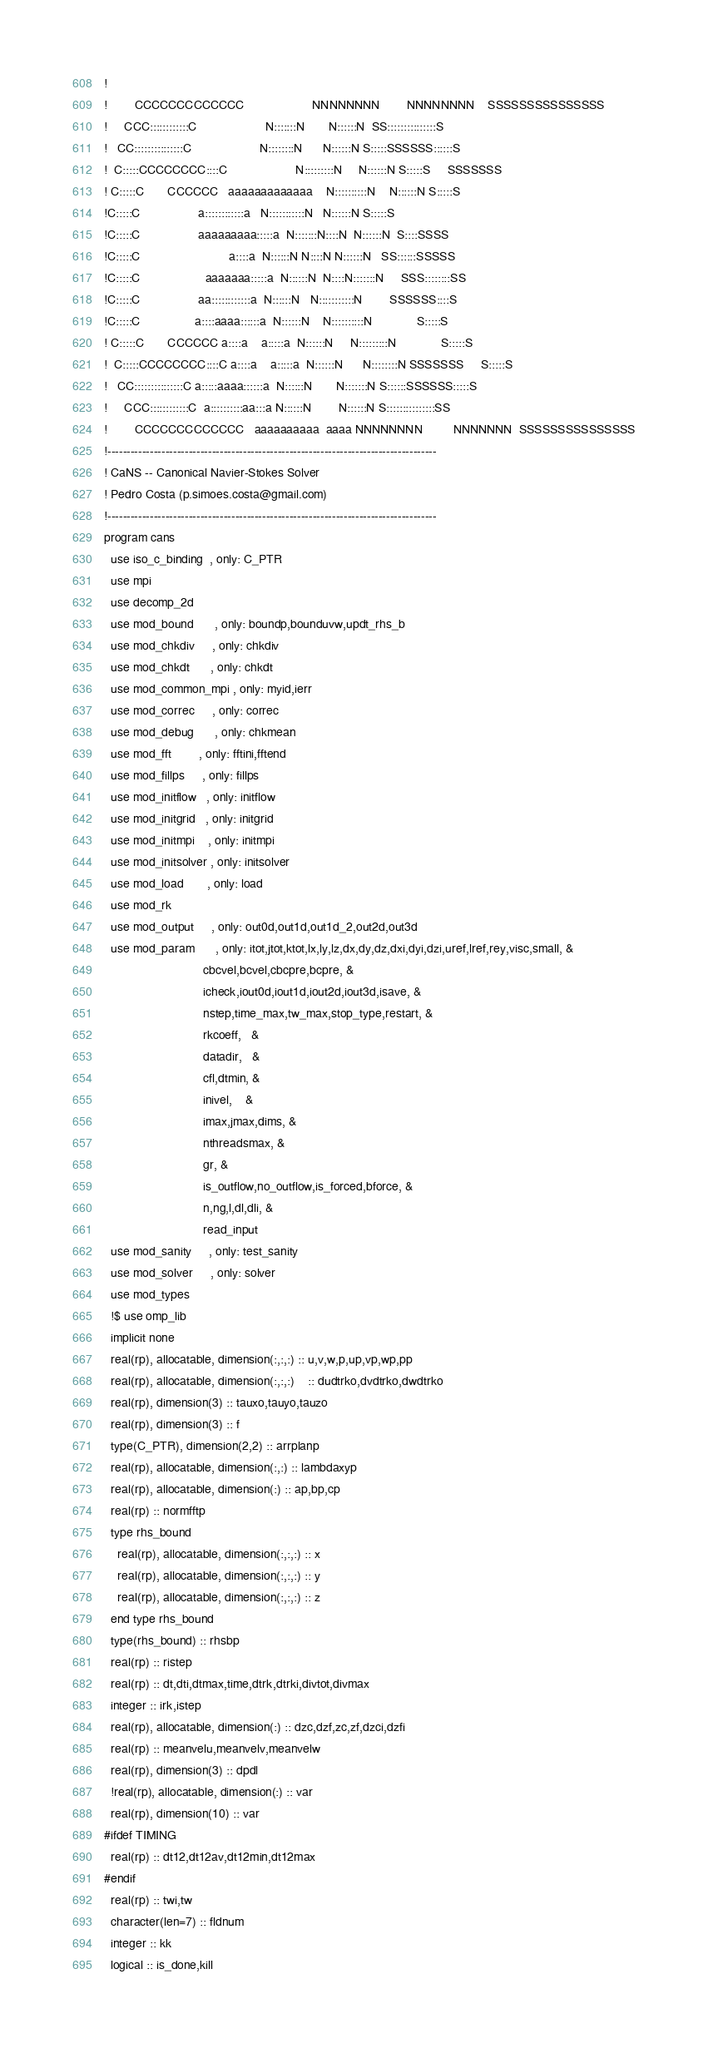Convert code to text. <code><loc_0><loc_0><loc_500><loc_500><_FORTRAN_>!
!        CCCCCCCCCCCCC                    NNNNNNNN        NNNNNNNN    SSSSSSSSSSSSSSS
!     CCC::::::::::::C                    N:::::::N       N::::::N  SS:::::::::::::::S
!   CC:::::::::::::::C                    N::::::::N      N::::::N S:::::SSSSSS::::::S
!  C:::::CCCCCCCC::::C                    N:::::::::N     N::::::N S:::::S     SSSSSSS
! C:::::C       CCCCCC   aaaaaaaaaaaaa    N::::::::::N    N::::::N S:::::S
!C:::::C                 a::::::::::::a   N:::::::::::N   N::::::N S:::::S
!C:::::C                 aaaaaaaaa:::::a  N:::::::N::::N  N::::::N  S::::SSSS
!C:::::C                          a::::a  N::::::N N::::N N::::::N   SS::::::SSSSS
!C:::::C                   aaaaaaa:::::a  N::::::N  N::::N:::::::N     SSS::::::::SS
!C:::::C                 aa::::::::::::a  N::::::N   N:::::::::::N        SSSSSS::::S
!C:::::C                a::::aaaa::::::a  N::::::N    N::::::::::N             S:::::S
! C:::::C       CCCCCC a::::a    a:::::a  N::::::N     N:::::::::N             S:::::S
!  C:::::CCCCCCCC::::C a::::a    a:::::a  N::::::N      N::::::::N SSSSSSS     S:::::S
!   CC:::::::::::::::C a:::::aaaa::::::a  N::::::N       N:::::::N S::::::SSSSSS:::::S
!     CCC::::::::::::C  a::::::::::aa:::a N::::::N        N::::::N S:::::::::::::::SS
!        CCCCCCCCCCCCC   aaaaaaaaaa  aaaa NNNNNNNN         NNNNNNN  SSSSSSSSSSSSSSS
!-------------------------------------------------------------------------------------
! CaNS -- Canonical Navier-Stokes Solver
! Pedro Costa (p.simoes.costa@gmail.com)
!-------------------------------------------------------------------------------------
program cans
  use iso_c_binding  , only: C_PTR
  use mpi
  use decomp_2d
  use mod_bound      , only: boundp,bounduvw,updt_rhs_b
  use mod_chkdiv     , only: chkdiv
  use mod_chkdt      , only: chkdt
  use mod_common_mpi , only: myid,ierr
  use mod_correc     , only: correc
  use mod_debug      , only: chkmean
  use mod_fft        , only: fftini,fftend
  use mod_fillps     , only: fillps
  use mod_initflow   , only: initflow
  use mod_initgrid   , only: initgrid
  use mod_initmpi    , only: initmpi
  use mod_initsolver , only: initsolver
  use mod_load       , only: load
  use mod_rk
  use mod_output     , only: out0d,out1d,out1d_2,out2d,out3d
  use mod_param      , only: itot,jtot,ktot,lx,ly,lz,dx,dy,dz,dxi,dyi,dzi,uref,lref,rey,visc,small, &
                             cbcvel,bcvel,cbcpre,bcpre, &
                             icheck,iout0d,iout1d,iout2d,iout3d,isave, &
                             nstep,time_max,tw_max,stop_type,restart, &
                             rkcoeff,   &
                             datadir,   &
                             cfl,dtmin, &
                             inivel,    &
                             imax,jmax,dims, &
                             nthreadsmax, &
                             gr, &
                             is_outflow,no_outflow,is_forced,bforce, &
                             n,ng,l,dl,dli, &
                             read_input
  use mod_sanity     , only: test_sanity
  use mod_solver     , only: solver
  use mod_types
  !$ use omp_lib
  implicit none
  real(rp), allocatable, dimension(:,:,:) :: u,v,w,p,up,vp,wp,pp
  real(rp), allocatable, dimension(:,:,:)    :: dudtrko,dvdtrko,dwdtrko
  real(rp), dimension(3) :: tauxo,tauyo,tauzo
  real(rp), dimension(3) :: f
  type(C_PTR), dimension(2,2) :: arrplanp
  real(rp), allocatable, dimension(:,:) :: lambdaxyp
  real(rp), allocatable, dimension(:) :: ap,bp,cp
  real(rp) :: normfftp
  type rhs_bound
    real(rp), allocatable, dimension(:,:,:) :: x
    real(rp), allocatable, dimension(:,:,:) :: y
    real(rp), allocatable, dimension(:,:,:) :: z
  end type rhs_bound 
  type(rhs_bound) :: rhsbp
  real(rp) :: ristep
  real(rp) :: dt,dti,dtmax,time,dtrk,dtrki,divtot,divmax
  integer :: irk,istep
  real(rp), allocatable, dimension(:) :: dzc,dzf,zc,zf,dzci,dzfi
  real(rp) :: meanvelu,meanvelv,meanvelw
  real(rp), dimension(3) :: dpdl
  !real(rp), allocatable, dimension(:) :: var
  real(rp), dimension(10) :: var
#ifdef TIMING
  real(rp) :: dt12,dt12av,dt12min,dt12max
#endif
  real(rp) :: twi,tw
  character(len=7) :: fldnum
  integer :: kk
  logical :: is_done,kill
</code> 